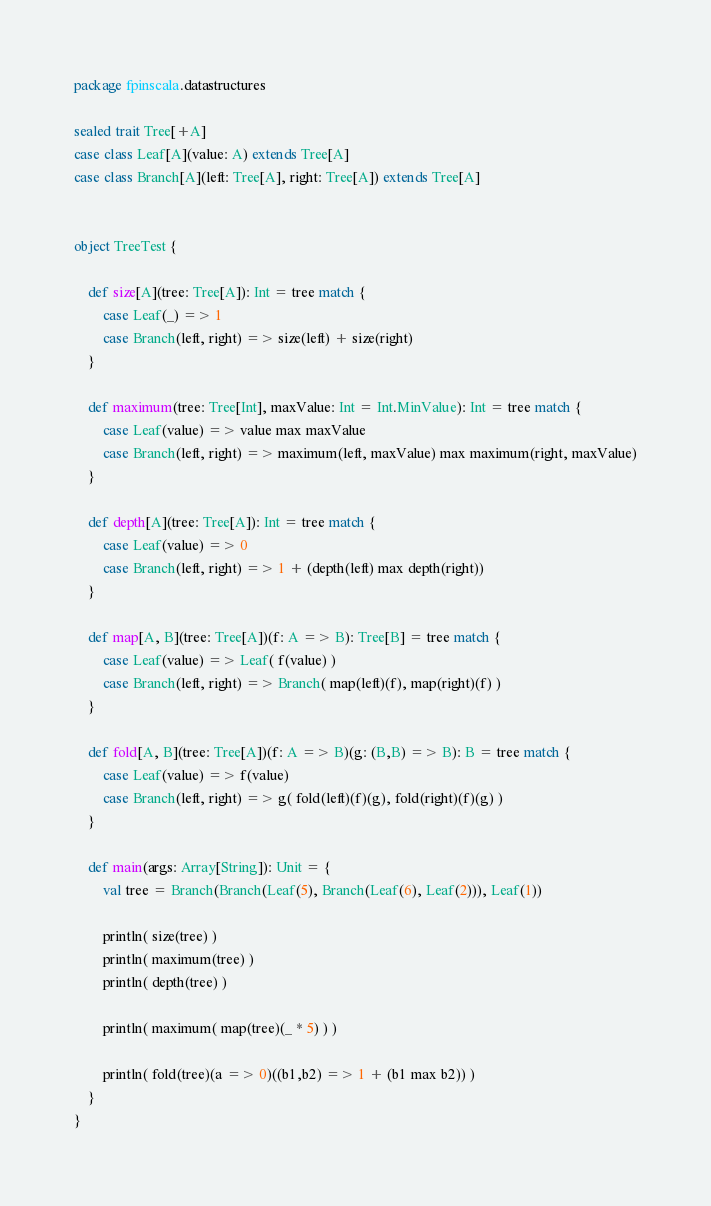<code> <loc_0><loc_0><loc_500><loc_500><_Scala_>package fpinscala.datastructures

sealed trait Tree[+A]
case class Leaf[A](value: A) extends Tree[A]
case class Branch[A](left: Tree[A], right: Tree[A]) extends Tree[A]


object TreeTest {

    def size[A](tree: Tree[A]): Int = tree match {
        case Leaf(_) => 1
        case Branch(left, right) => size(left) + size(right)
    }

    def maximum(tree: Tree[Int], maxValue: Int = Int.MinValue): Int = tree match {
        case Leaf(value) => value max maxValue
        case Branch(left, right) => maximum(left, maxValue) max maximum(right, maxValue)
    }

    def depth[A](tree: Tree[A]): Int = tree match {
        case Leaf(value) => 0
        case Branch(left, right) => 1 + (depth(left) max depth(right))
    }

    def map[A, B](tree: Tree[A])(f: A => B): Tree[B] = tree match {
        case Leaf(value) => Leaf( f(value) )
        case Branch(left, right) => Branch( map(left)(f), map(right)(f) )
    }

    def fold[A, B](tree: Tree[A])(f: A => B)(g: (B,B) => B): B = tree match {
        case Leaf(value) => f(value)
        case Branch(left, right) => g( fold(left)(f)(g), fold(right)(f)(g) )
    }

    def main(args: Array[String]): Unit = {
        val tree = Branch(Branch(Leaf(5), Branch(Leaf(6), Leaf(2))), Leaf(1))

        println( size(tree) )
        println( maximum(tree) )
        println( depth(tree) )

        println( maximum( map(tree)(_ * 5) ) )

        println( fold(tree)(a => 0)((b1,b2) => 1 + (b1 max b2)) )
    }
}
</code> 